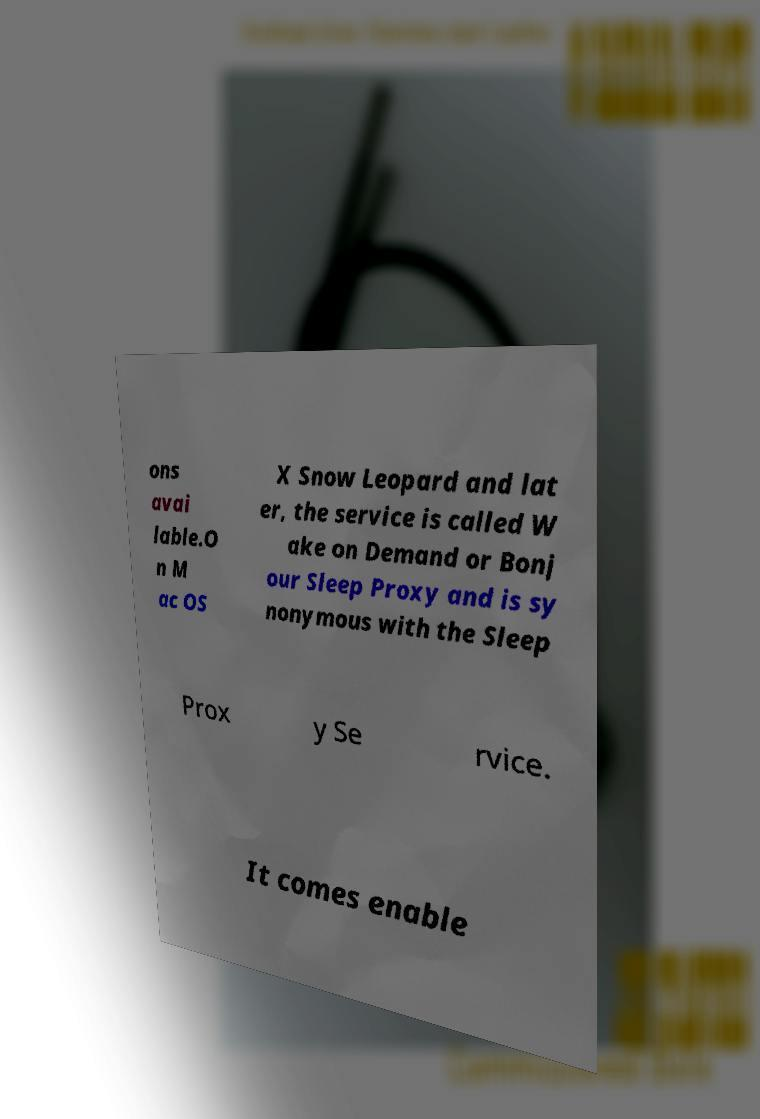Can you read and provide the text displayed in the image?This photo seems to have some interesting text. Can you extract and type it out for me? ons avai lable.O n M ac OS X Snow Leopard and lat er, the service is called W ake on Demand or Bonj our Sleep Proxy and is sy nonymous with the Sleep Prox y Se rvice. It comes enable 